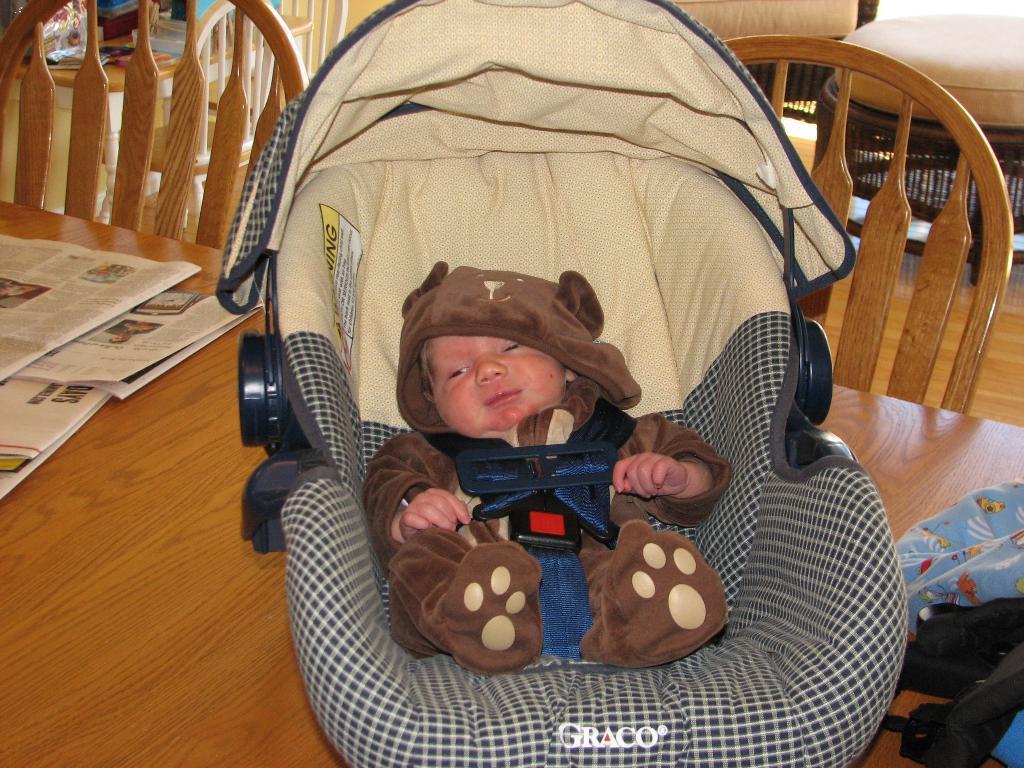Can you describe this image briefly? In this image there is a baby chair with a baby inside it placed on the top of the table. There are few newspapers also placed on the top of the table. In the background of the image there are few chairs present. 